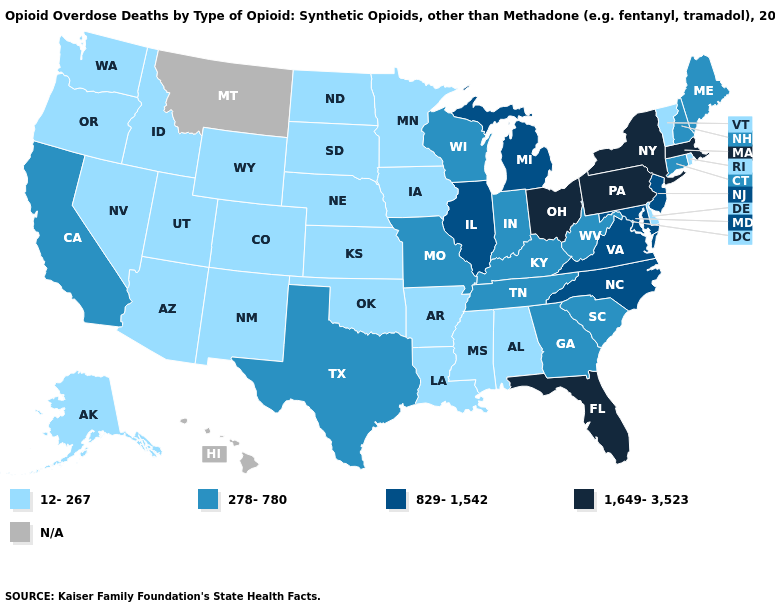Name the states that have a value in the range 12-267?
Write a very short answer. Alabama, Alaska, Arizona, Arkansas, Colorado, Delaware, Idaho, Iowa, Kansas, Louisiana, Minnesota, Mississippi, Nebraska, Nevada, New Mexico, North Dakota, Oklahoma, Oregon, Rhode Island, South Dakota, Utah, Vermont, Washington, Wyoming. What is the value of Missouri?
Quick response, please. 278-780. How many symbols are there in the legend?
Quick response, please. 5. What is the highest value in the West ?
Be succinct. 278-780. Among the states that border Illinois , does Kentucky have the highest value?
Write a very short answer. Yes. Does Pennsylvania have the lowest value in the Northeast?
Be succinct. No. Which states hav the highest value in the MidWest?
Write a very short answer. Ohio. Is the legend a continuous bar?
Quick response, please. No. What is the highest value in states that border Alabama?
Give a very brief answer. 1,649-3,523. Which states have the lowest value in the MidWest?
Write a very short answer. Iowa, Kansas, Minnesota, Nebraska, North Dakota, South Dakota. Which states have the highest value in the USA?
Give a very brief answer. Florida, Massachusetts, New York, Ohio, Pennsylvania. Does Oklahoma have the lowest value in the South?
Keep it brief. Yes. Which states have the lowest value in the MidWest?
Short answer required. Iowa, Kansas, Minnesota, Nebraska, North Dakota, South Dakota. 